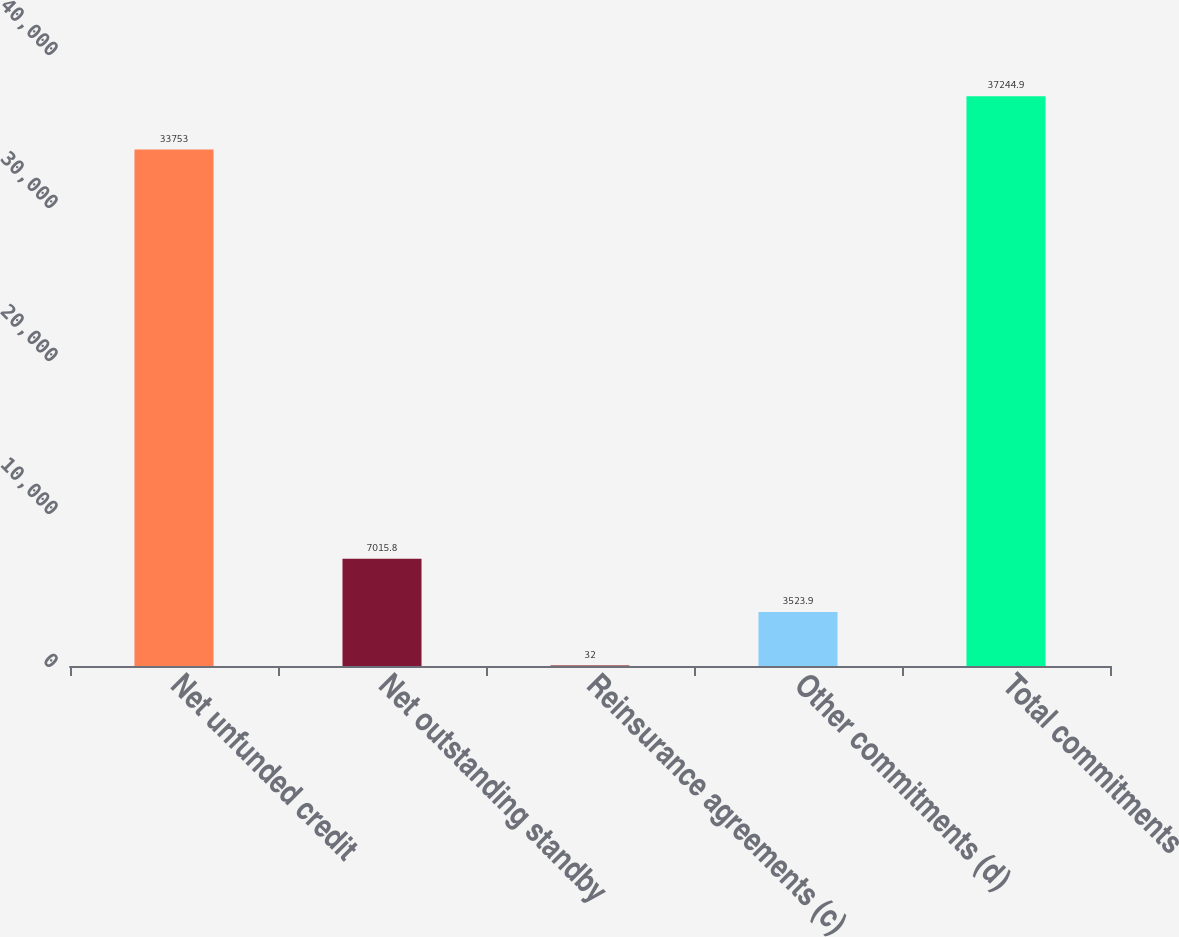<chart> <loc_0><loc_0><loc_500><loc_500><bar_chart><fcel>Net unfunded credit<fcel>Net outstanding standby<fcel>Reinsurance agreements (c)<fcel>Other commitments (d)<fcel>Total commitments<nl><fcel>33753<fcel>7015.8<fcel>32<fcel>3523.9<fcel>37244.9<nl></chart> 